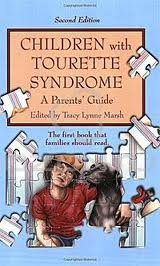What is the version of this book? This publication is the 2nd edition, providing updated and comprehensive insights since its first release. 